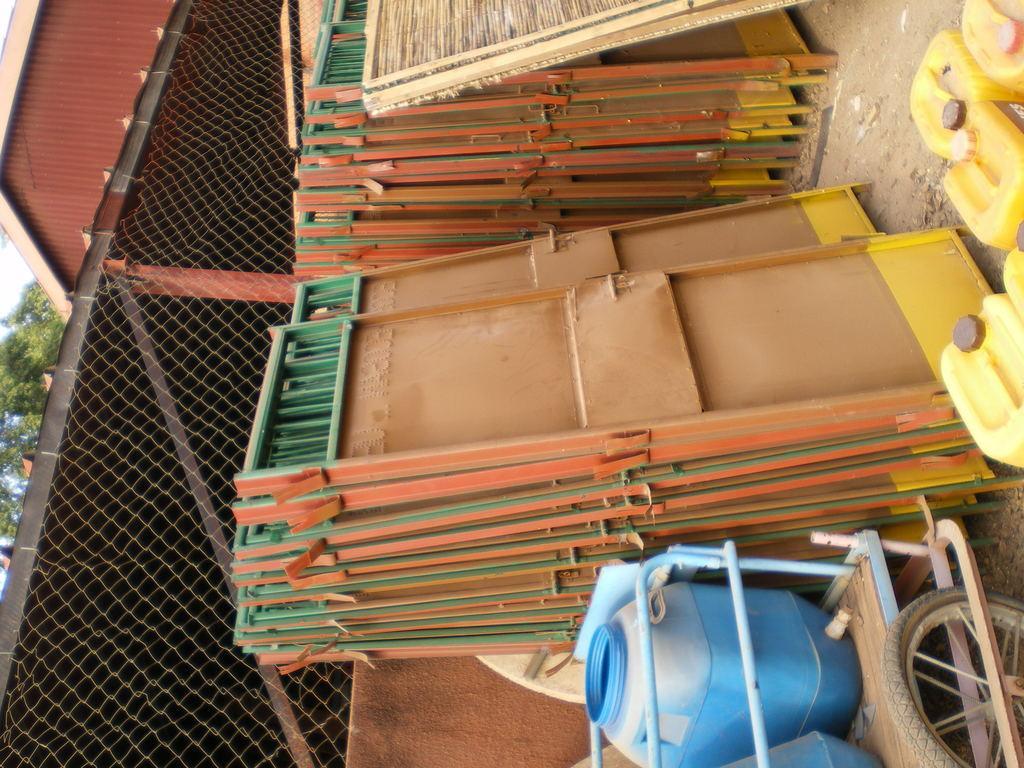How would you summarize this image in a sentence or two? In the image we can see the cart, in the car we can see there are plastic objects. Here we can see gates, mesh, tree and the sky. Here we can see the tire. 